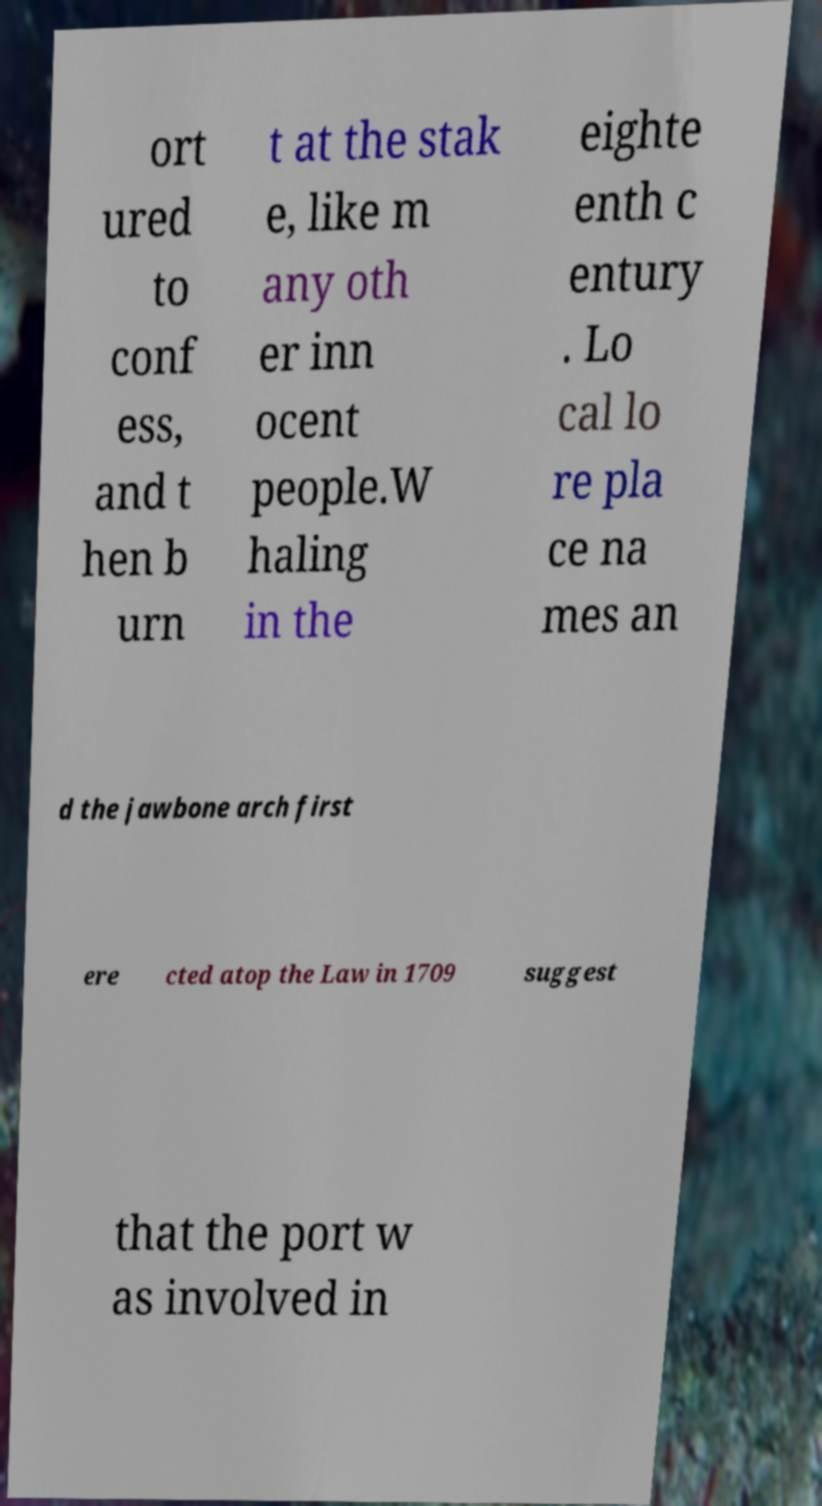Please read and relay the text visible in this image. What does it say? ort ured to conf ess, and t hen b urn t at the stak e, like m any oth er inn ocent people.W haling in the eighte enth c entury . Lo cal lo re pla ce na mes an d the jawbone arch first ere cted atop the Law in 1709 suggest that the port w as involved in 